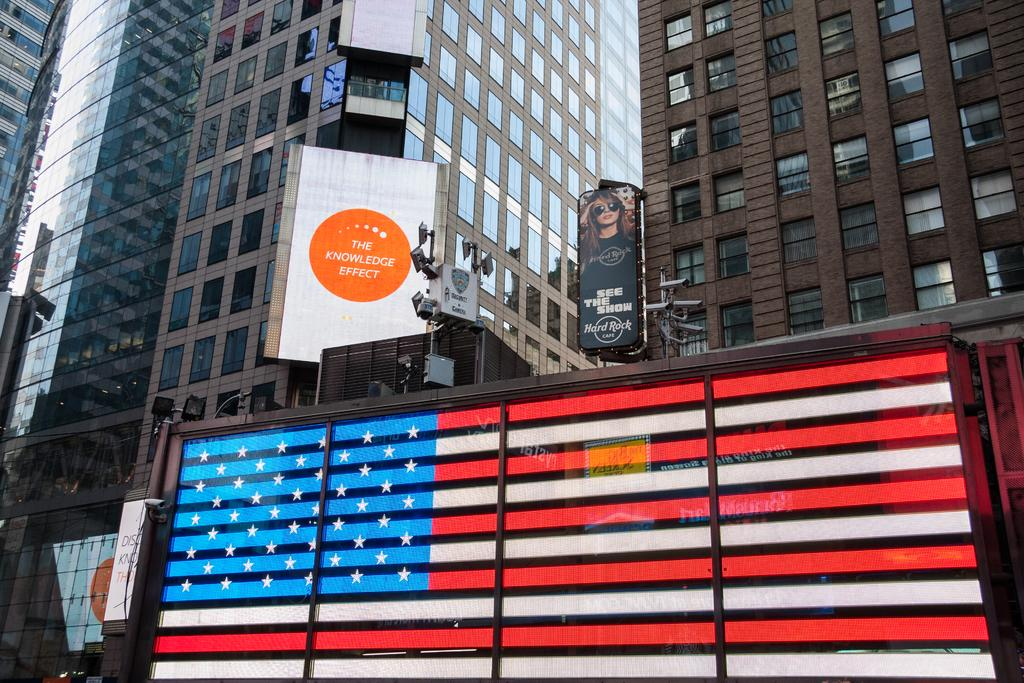What type of buildings can be seen in the image? There are many skyscrapers in the image. What is displayed on the skyscrapers? The skyscrapers have ad banners on them. What color of ink is used for the parent's signature on the beam in the image? There is no parent or signature on a beam present in the image. 